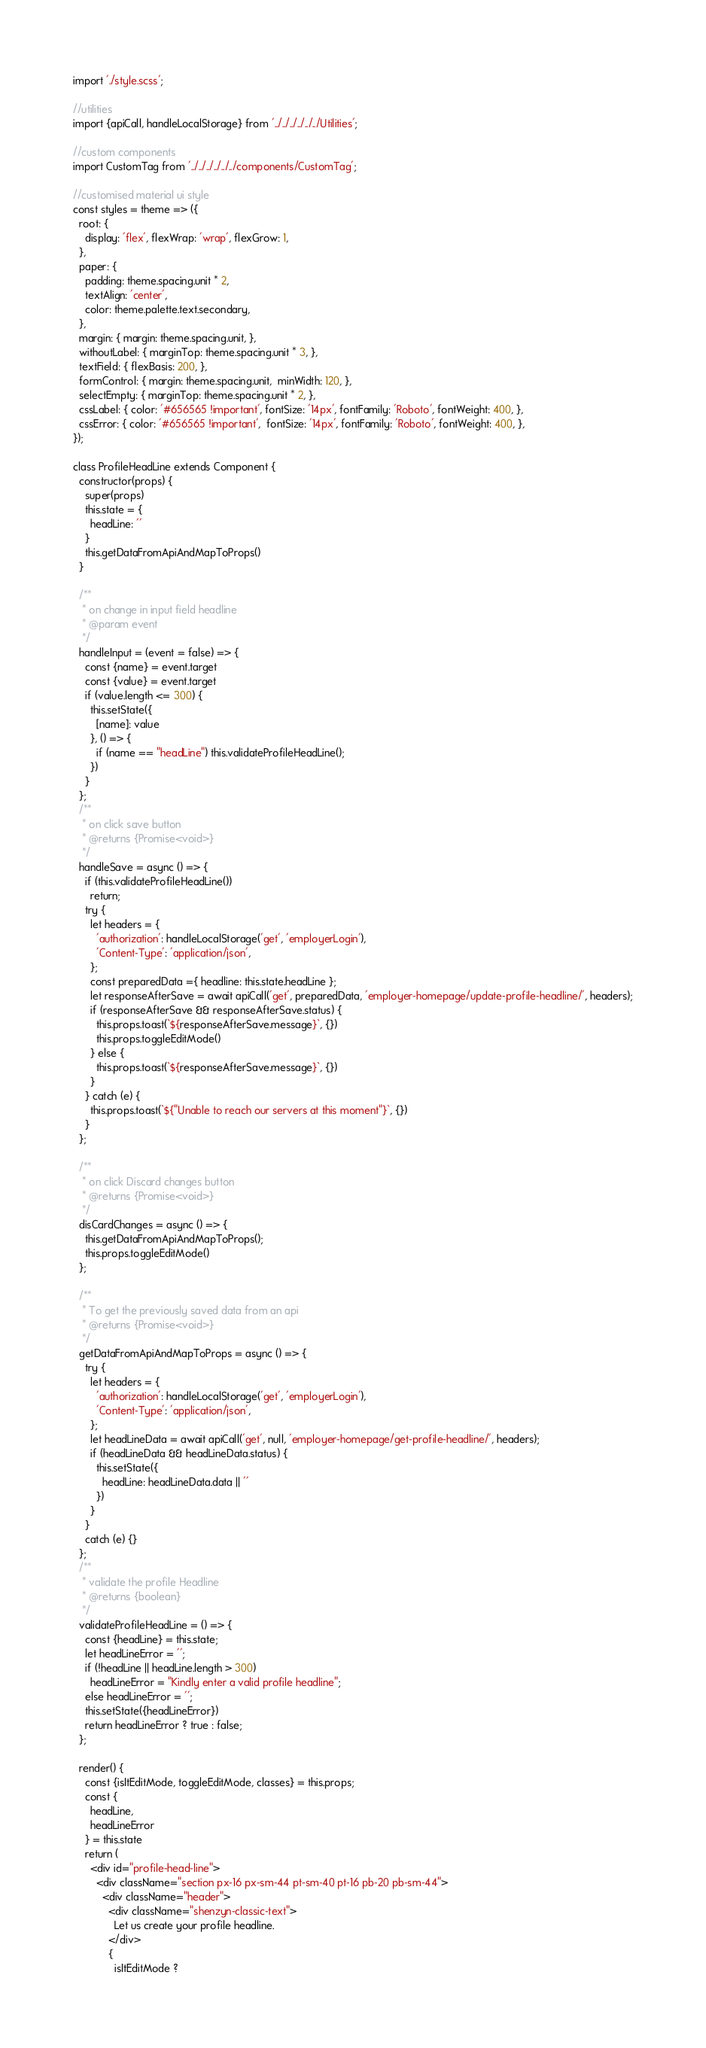Convert code to text. <code><loc_0><loc_0><loc_500><loc_500><_JavaScript_>import './style.scss';

//utilities
import {apiCall, handleLocalStorage} from '../../../../../../Utilities';

//custom components
import CustomTag from '../../../../../../components/CustomTag';

//customised material ui style
const styles = theme => ({
  root: {
    display: 'flex', flexWrap: 'wrap', flexGrow: 1,
  },
  paper: {
    padding: theme.spacing.unit * 2,
    textAlign: 'center',
    color: theme.palette.text.secondary,
  },
  margin: { margin: theme.spacing.unit, },
  withoutLabel: { marginTop: theme.spacing.unit * 3, },
  textField: { flexBasis: 200, },
  formControl: { margin: theme.spacing.unit,  minWidth: 120, },
  selectEmpty: { marginTop: theme.spacing.unit * 2, },
  cssLabel: { color: '#656565 !important', fontSize: '14px', fontFamily: 'Roboto', fontWeight: 400, },
  cssError: { color: '#656565 !important',  fontSize: '14px', fontFamily: 'Roboto', fontWeight: 400, },
});

class ProfileHeadLine extends Component {
  constructor(props) {
    super(props)
    this.state = {
      headLine: ''
    }
    this.getDataFromApiAndMapToProps()
  }

  /**
   * on change in input field headline
   * @param event
   */
  handleInput = (event = false) => {
    const {name} = event.target
    const {value} = event.target
    if (value.length <= 300) {
      this.setState({
        [name]: value
      }, () => {
        if (name == "headLine") this.validateProfileHeadLine();
      })
    }
  };
  /**
   * on click save button
   * @returns {Promise<void>}
   */
  handleSave = async () => {
    if (this.validateProfileHeadLine())
      return;
    try {
      let headers = {
        'authorization': handleLocalStorage('get', 'employerLogin'),
        'Content-Type': 'application/json',
      };
      const preparedData ={ headline: this.state.headLine };
      let responseAfterSave = await apiCall('get', preparedData, 'employer-homepage/update-profile-headline/', headers);
      if (responseAfterSave && responseAfterSave.status) {
        this.props.toast(`${responseAfterSave.message}`, {})
        this.props.toggleEditMode()
      } else {
        this.props.toast(`${responseAfterSave.message}`, {})
      }
    } catch (e) {
      this.props.toast(`${"Unable to reach our servers at this moment"}`, {})
    }
  };

  /**
   * on click Discard changes button
   * @returns {Promise<void>}
   */
  disCardChanges = async () => {
    this.getDataFromApiAndMapToProps();
    this.props.toggleEditMode()
  };

  /**
   * To get the previously saved data from an api
   * @returns {Promise<void>}
   */
  getDataFromApiAndMapToProps = async () => {
    try {
      let headers = {
        'authorization': handleLocalStorage('get', 'employerLogin'),
        'Content-Type': 'application/json',
      };
      let headLineData = await apiCall('get', null, 'employer-homepage/get-profile-headline/', headers);
      if (headLineData && headLineData.status) {
        this.setState({
          headLine: headLineData.data || ''
        })
      }
    }
    catch (e) {}
  };
  /**
   * validate the profile Headline
   * @returns {boolean}
   */
  validateProfileHeadLine = () => {
    const {headLine} = this.state;
    let headLineError = '';
    if (!headLine || headLine.length > 300)
      headLineError = "Kindly enter a valid profile headline";
    else headLineError = '';
    this.setState({headLineError})
    return headLineError ? true : false;
  };

  render() {
    const {isItEditMode, toggleEditMode, classes} = this.props;
    const {
      headLine,
      headLineError
    } = this.state
    return (
      <div id="profile-head-line">
        <div className="section px-16 px-sm-44 pt-sm-40 pt-16 pb-20 pb-sm-44">
          <div className="header">
            <div className="shenzyn-classic-text">
              Let us create your profile headline.
            </div>
            {
              isItEditMode ?</code> 